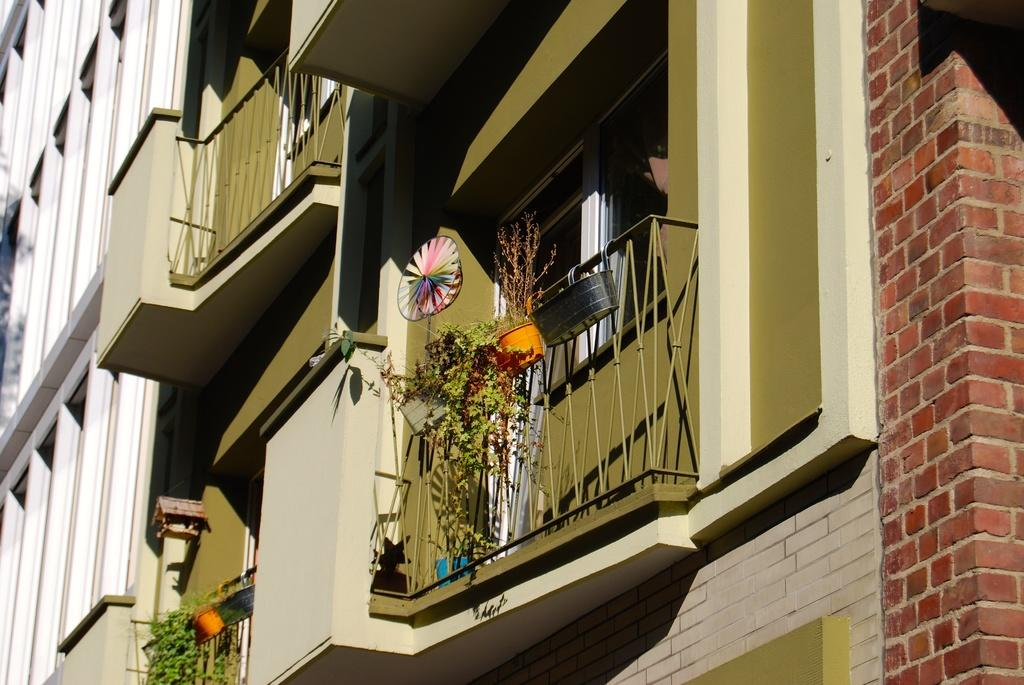What type of structures can be seen in the image? There are buildings in the image. Are there any specific features of the buildings that can be observed? Yes, there are balconies visible in the image. What else is present in the image besides the buildings? There are objects and plants present in the image. What type of adjustment is the band making in the image? There is no band present in the image, so no adjustments can be observed. 